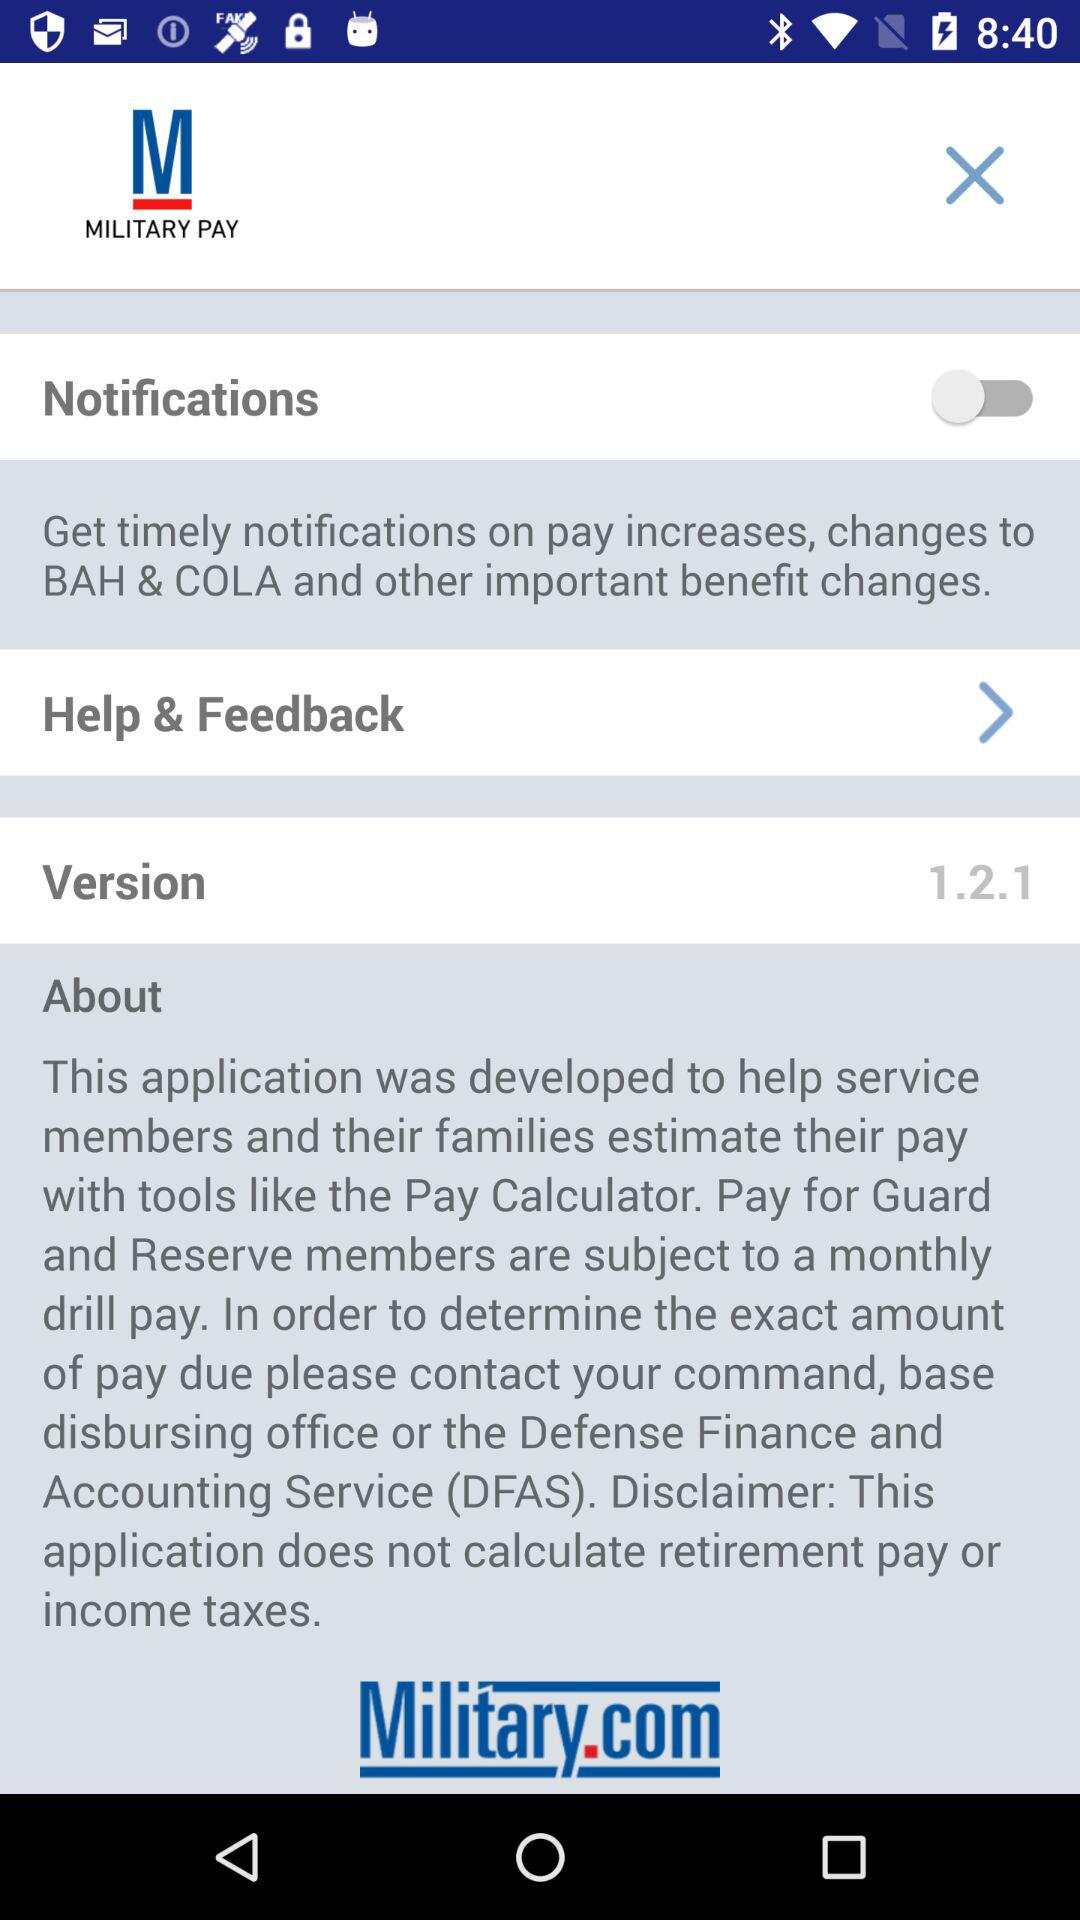What is the version? The version is 1.2.1. 